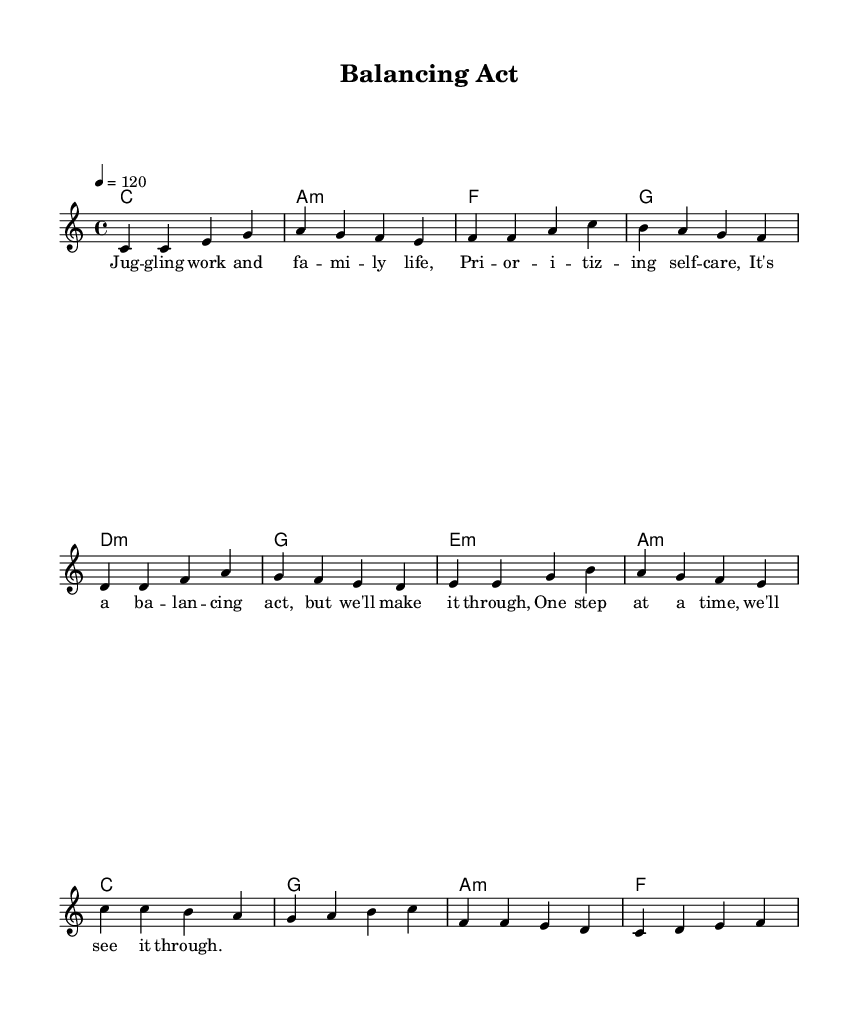What is the key signature of this music? The key signature is C major, which has no sharps or flats.
Answer: C major What is the time signature of this piece? The time signature indicated at the beginning of the music is 4/4, meaning there are four beats in each measure.
Answer: 4/4 What is the tempo marking for this piece? The tempo marking specifically indicates a tempo of 120 beats per minute, which suggests a moderately fast pace.
Answer: 120 How many measures are in the chorus section? By counting the measures under the chorus label, there are four measures present in that section.
Answer: 4 What is the last note of the melody? In the melody, the last note as seen in the final measure is an F note, which concludes the melodic phrase.
Answer: F Which chord follows the D minor chord in the pre-chorus? In the chord progression of the pre-chorus, the chord that follows D minor is a G major chord as indicated in the harmonies.
Answer: G What is the overall theme represented in the lyrics? The lyrics illustrate the theme of managing work and family life while emphasizing the importance of self-care.
Answer: Balancing act 